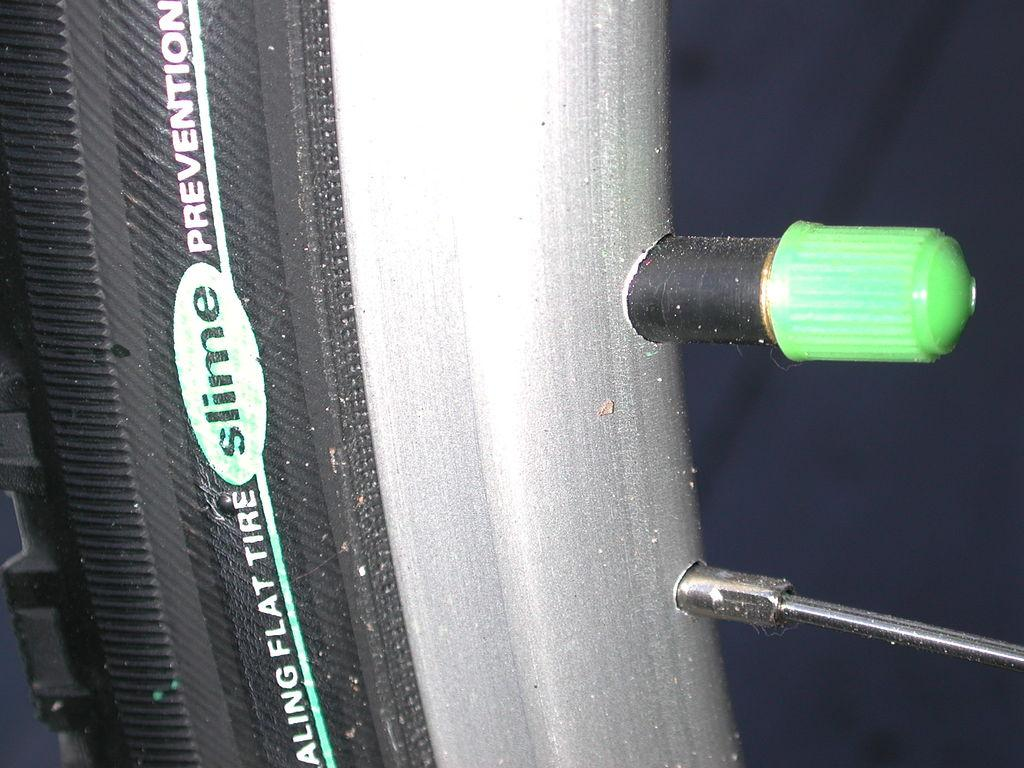<image>
Render a clear and concise summary of the photo. A picture of some sort of tire with a green plug labeled SLIME. 